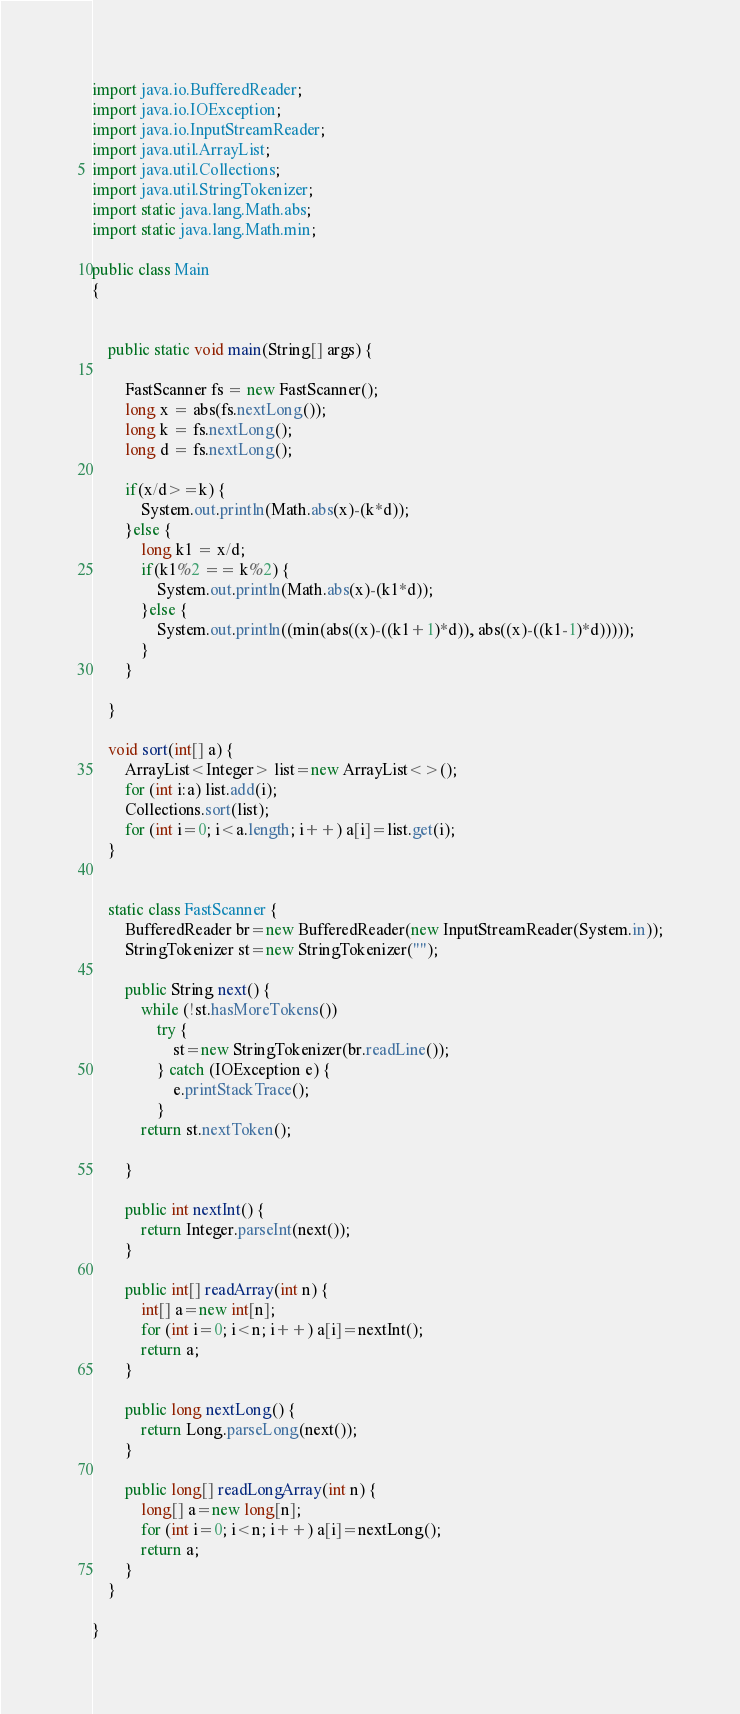<code> <loc_0><loc_0><loc_500><loc_500><_Java_>import java.io.BufferedReader; 
import java.io.IOException;
import java.io.InputStreamReader;
import java.util.ArrayList;
import java.util.Collections;
import java.util.StringTokenizer;
import static java.lang.Math.abs;
import static java.lang.Math.min;

public class Main
{
	
	
	public static void main(String[] args) {
	
		FastScanner fs = new FastScanner();
		long x = abs(fs.nextLong());
		long k = fs.nextLong();
		long d = fs.nextLong();
		
		if(x/d>=k) {
			System.out.println(Math.abs(x)-(k*d)); 
		}else {
			long k1 = x/d;
			if(k1%2 == k%2) {
				System.out.println(Math.abs(x)-(k1*d));
			}else {
				System.out.println((min(abs((x)-((k1+1)*d)), abs((x)-((k1-1)*d)))));
			}
		}
	
	}

	void sort(int[] a) {
		ArrayList<Integer> list=new ArrayList<>();
		for (int i:a) list.add(i);
		Collections.sort(list);
		for (int i=0; i<a.length; i++) a[i]=list.get(i);
	}
	
	
	static class FastScanner {
		BufferedReader br=new BufferedReader(new InputStreamReader(System.in));
		StringTokenizer st=new StringTokenizer("");
		
		public String next() {
			while (!st.hasMoreTokens())
				try {
					st=new StringTokenizer(br.readLine());
				} catch (IOException e) {
					e.printStackTrace();
				}
			return st.nextToken();
			
		}
		
		public int nextInt() {
			return Integer.parseInt(next());
		}
		
		public int[] readArray(int n) {
			int[] a=new int[n];
			for (int i=0; i<n; i++) a[i]=nextInt();
			return a;
		}
		
		public long nextLong() {
			return Long.parseLong(next());
		}
		
		public long[] readLongArray(int n) {
			long[] a=new long[n];
			for (int i=0; i<n; i++) a[i]=nextLong();
			return a;
		}
	}
 
}



</code> 